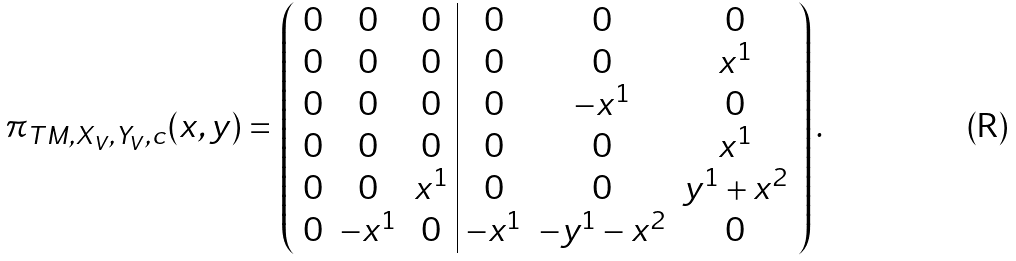Convert formula to latex. <formula><loc_0><loc_0><loc_500><loc_500>\pi _ { T M , X _ { V } , Y _ { V } , c } ( { x } , { y } ) = \left ( \begin{array} { c c c | c c c } 0 & 0 & 0 & 0 & 0 & 0 \\ 0 & 0 & 0 & 0 & 0 & x ^ { 1 } \\ 0 & 0 & 0 & 0 & - x ^ { 1 } & 0 \\ 0 & 0 & 0 & 0 & 0 & x ^ { 1 } \\ 0 & 0 & x ^ { 1 } & 0 & 0 & y ^ { 1 } + x ^ { 2 } \\ 0 & - x ^ { 1 } & 0 & - x ^ { 1 } & - y ^ { 1 } - x ^ { 2 } & 0 \\ \end{array} \right ) .</formula> 